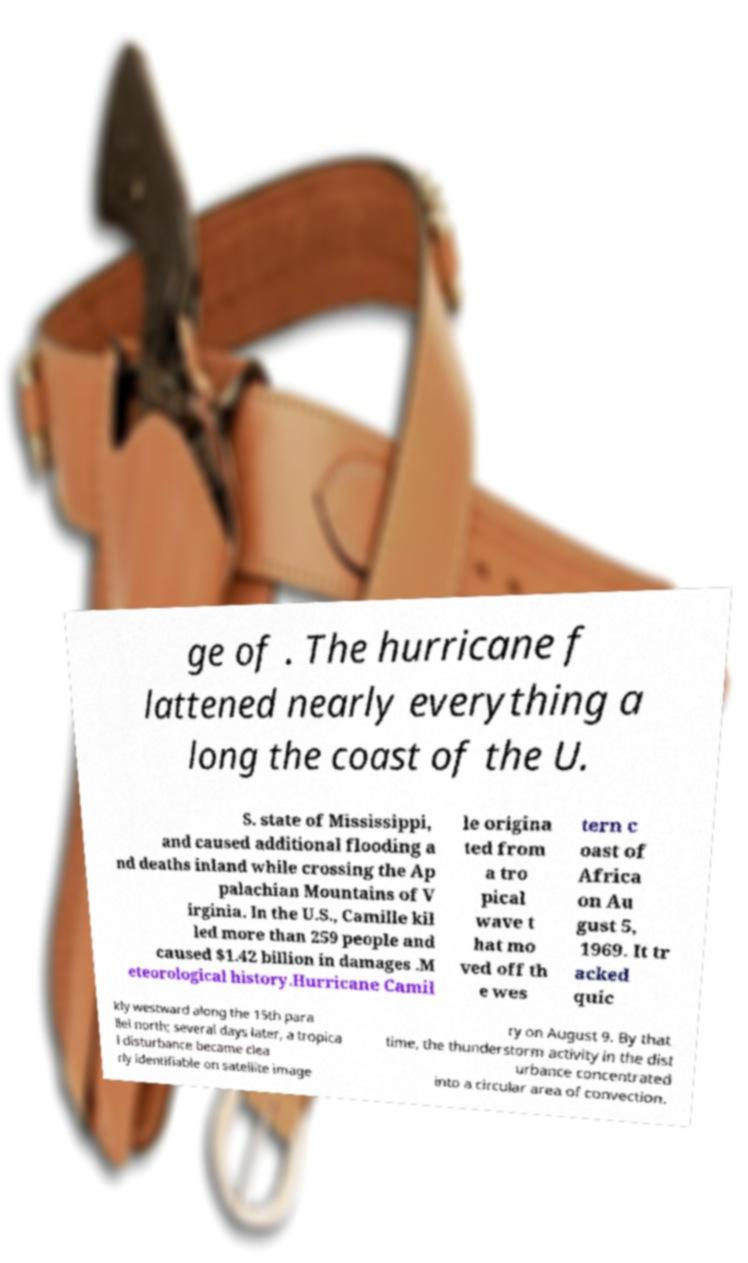Please identify and transcribe the text found in this image. ge of . The hurricane f lattened nearly everything a long the coast of the U. S. state of Mississippi, and caused additional flooding a nd deaths inland while crossing the Ap palachian Mountains of V irginia. In the U.S., Camille kil led more than 259 people and caused $1.42 billion in damages .M eteorological history.Hurricane Camil le origina ted from a tro pical wave t hat mo ved off th e wes tern c oast of Africa on Au gust 5, 1969. It tr acked quic kly westward along the 15th para llel north; several days later, a tropica l disturbance became clea rly identifiable on satellite image ry on August 9. By that time, the thunderstorm activity in the dist urbance concentrated into a circular area of convection. 